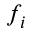<formula> <loc_0><loc_0><loc_500><loc_500>f _ { i }</formula> 